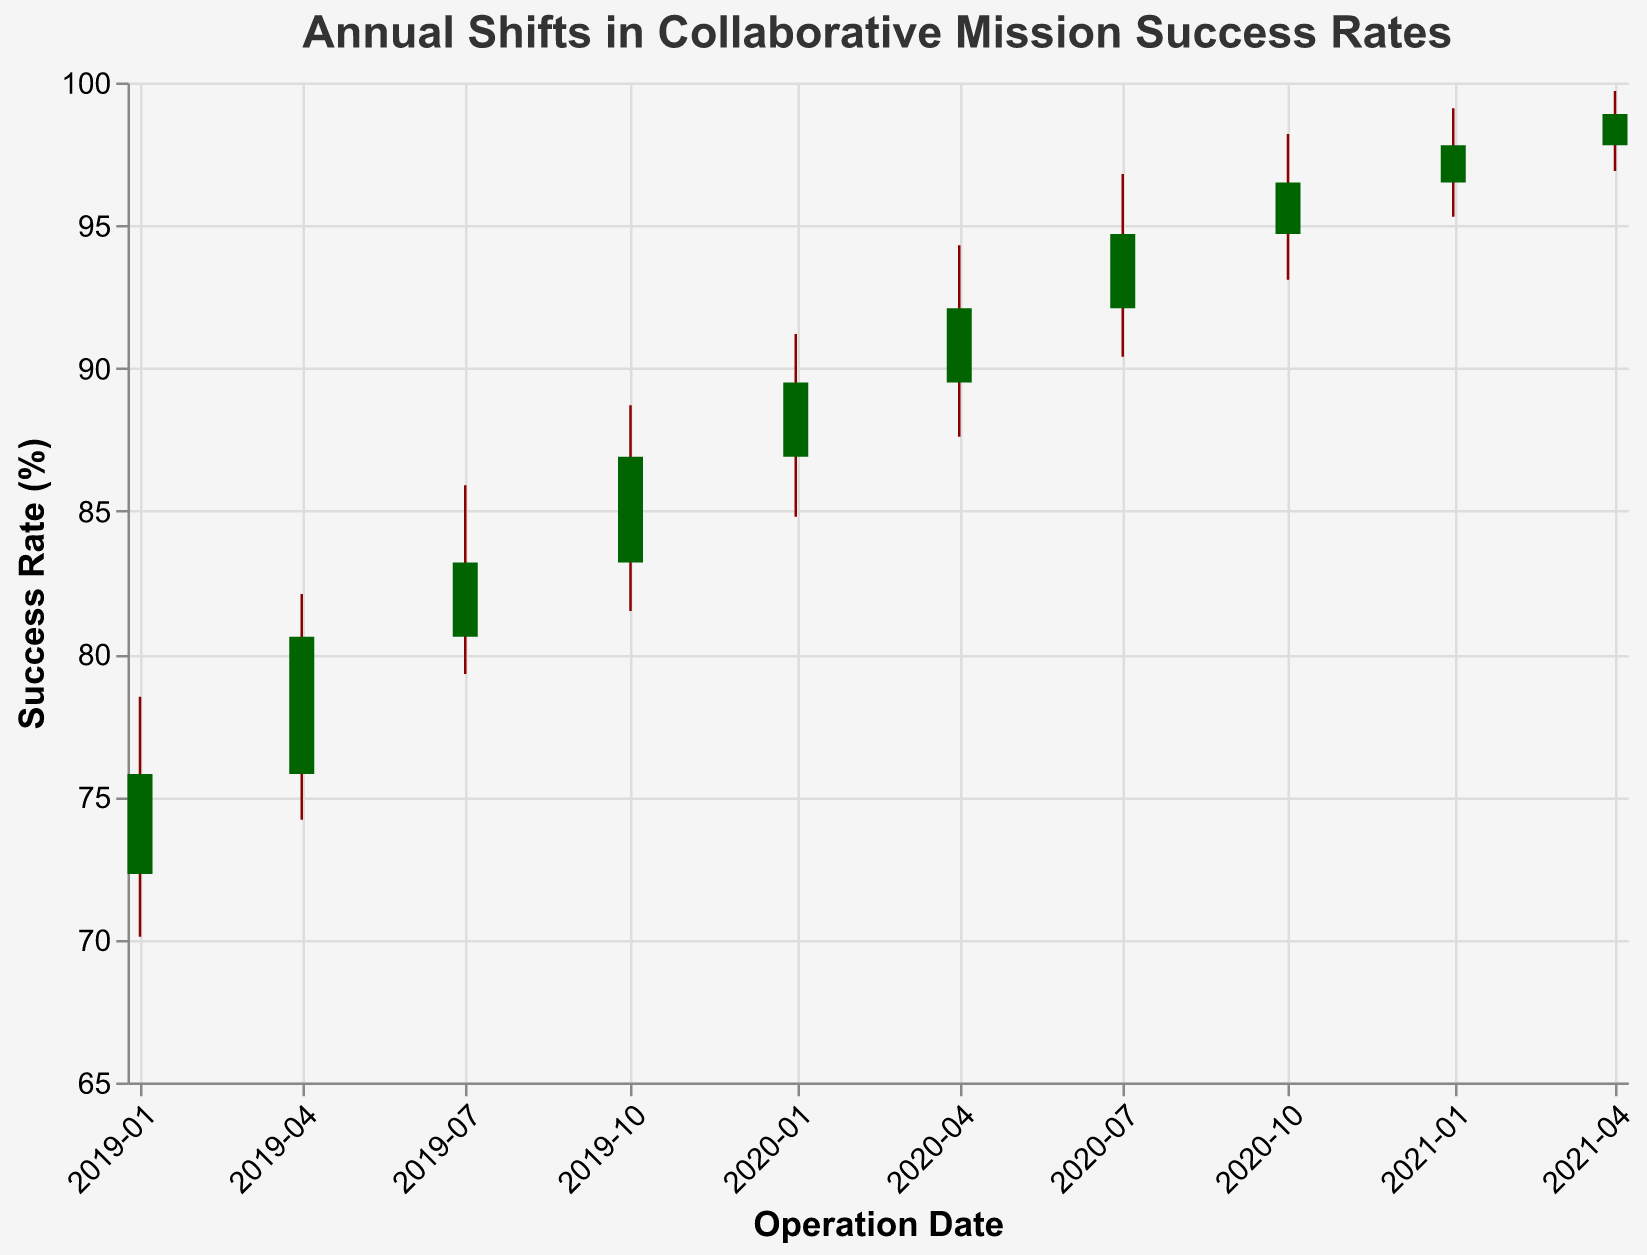What is the title of the chart? The title is located at the top of the chart, and it states the main subject of the visual representation.
Answer: Annual Shifts in Collaborative Mission Success Rates Which operation has the highest success rate 'High' value? Look for the highest 'High' value among all operations in the tooltip or by visually inspecting the chart's upper-most ends for each bar.
Answer: Unified Front What is the operation date with the lowest closing success rate? Check the 'Close' values and identify the lowest one. Find out the date associated with that value.
Answer: Operation Unified Shield on 2019-01-01 What is the average closing success rate for the year 2020? List out 'Close' values for 2020: (89.5, 92.1, 94.7, 96.5). Find the sum of these values and then divide by the number of observations. (89.5 + 92.1 + 94.7 + 96.5) / 4 = 372.8 / 4 = 93.2
Answer: 93.2 Between which dates was the highest increase in closing success rates observed? Calculate the difference in 'Close' values between successive dates and identify the pair with the maximum increase. The highest increase occurs between 2019-01-01 (75.8) and 2019-04-01 (80.6): 80.6 - 75.8 = 4.8. No other pairs have a higher increase.
Answer: 2019-01-01 and 2019-04-01 How many operations had a positive change from 'Open' to 'Close'? For each operation, compare the 'Open' and 'Close' values. Count the ones where 'Close' is greater than 'Open'.
Answer: 7 Which operation had the smallest range between 'Low' and 'High' values? Calculate the range (High - Low) for each operation and find the smallest one. The smallest range is 2.6 for Comrades' Resolve (99.1 - 95.3 = 3.8, which is smaller than other ranges).
Answer: Comrades' Resolve on 2021-01-01 What was the success rate at the start (Open) and end (Close) of the data for 'Unified Front'? Check the 'Open' and 'Close' values for the operation titled 'Unified Front'.
Answer: Open: 97.8, Close: 98.9 Which operation indicated a higher variability in success rate between its lowest and highest values compared to 'Operation Unified Shield'? Compare the ranges for both operations ('High' - 'Low'). Operation Unified Shield: 78.5 - 70.1 = 8.4. Identify any operation with a higher range. 'Alliance Stronghold': 88.7 - 81.5 = 7.2 < 8.4 so check others. 'Joint Task Force Ares': 82.1 - 74.2 = 7.9 < 8.4. 'Combined Effort Vanguard': 85.9 - 79.3 = 6.6 < 8.4. 'Solidarity Storm': 91.2 - 84.8 = 6.4 < 8.4. 'Unity Bulwark': 94.3 - 87.6 = 6.7 < 8.4. 'Collective Sentinel': 96.8 - 90.4 = 6.4 < 8.4. 'Fraternal Aegis': 98.2 - 93.1 = 5.1 < 8.4. 'Comrades Resolve': 99.1 - 95.3 = 3.8 < 8.4. 'Unified Front': 99.7 - 96.9 = 2.8 < 8.4. None display higher variability.
Answer: None 